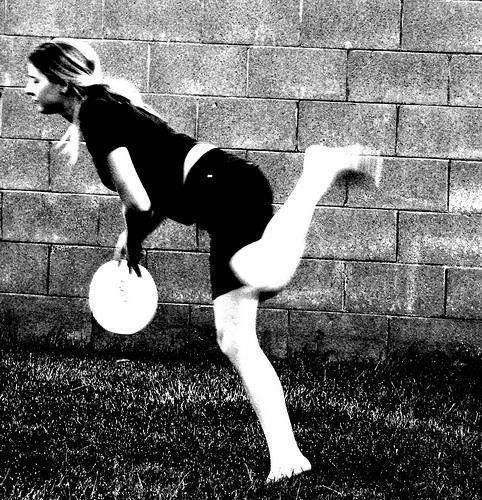How many legs is the woman standing on?
Give a very brief answer. 1. How many people are pictured?
Give a very brief answer. 1. 